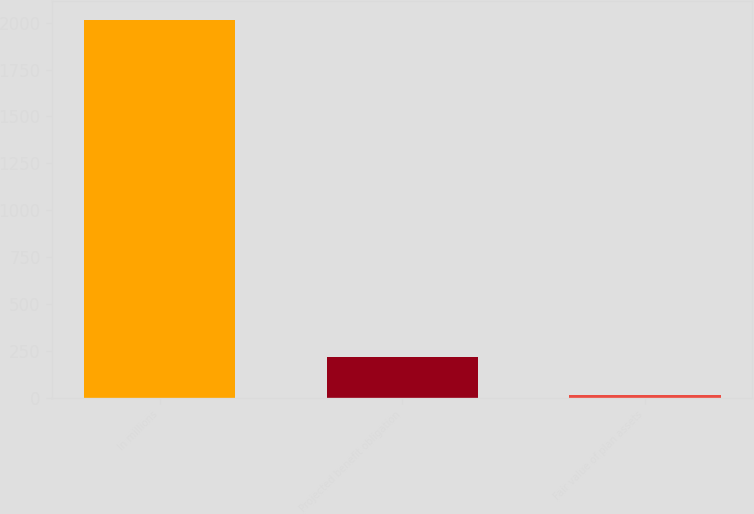Convert chart to OTSL. <chart><loc_0><loc_0><loc_500><loc_500><bar_chart><fcel>In millions<fcel>Projected benefit obligation<fcel>Fair value of plan assets<nl><fcel>2015<fcel>216.44<fcel>16.6<nl></chart> 